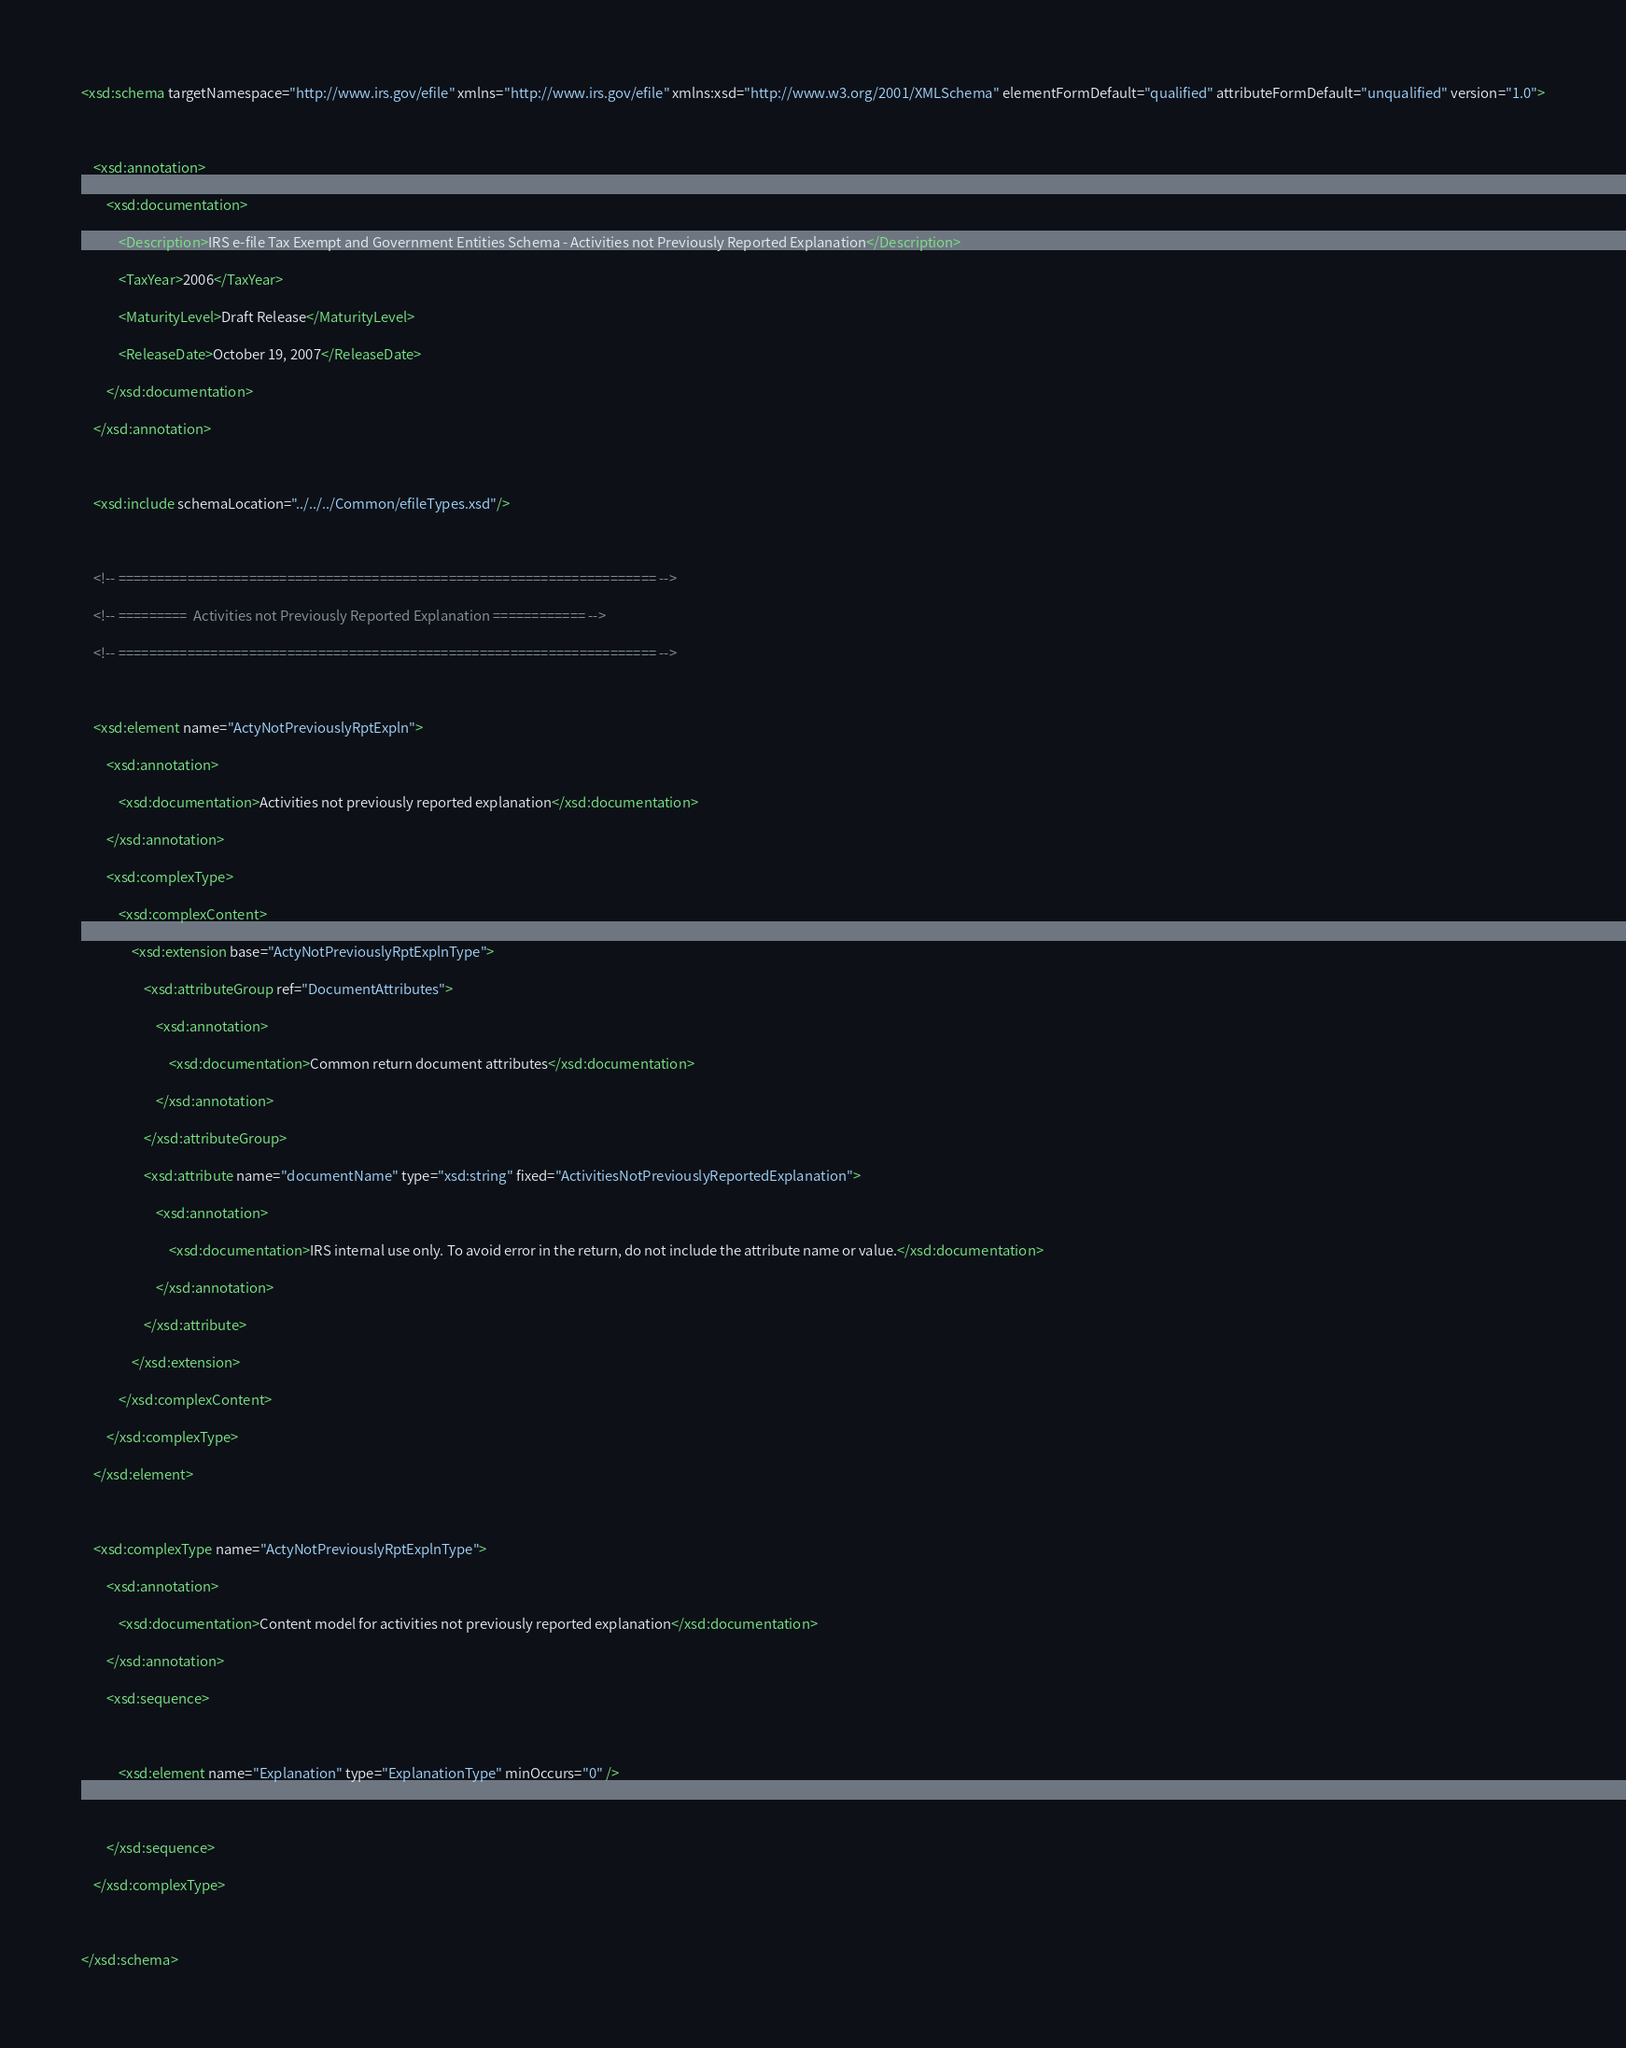Convert code to text. <code><loc_0><loc_0><loc_500><loc_500><_XML_><xsd:schema targetNamespace="http://www.irs.gov/efile" xmlns="http://www.irs.gov/efile" xmlns:xsd="http://www.w3.org/2001/XMLSchema" elementFormDefault="qualified" attributeFormDefault="unqualified" version="1.0">

	<xsd:annotation>
		<xsd:documentation>
			<Description>IRS e-file Tax Exempt and Government Entities Schema - Activities not Previously Reported Explanation</Description>
			<TaxYear>2006</TaxYear>
			<MaturityLevel>Draft Release</MaturityLevel>
			<ReleaseDate>October 19, 2007</ReleaseDate>			
		</xsd:documentation>
	</xsd:annotation>
	
	<xsd:include schemaLocation="../../../Common/efileTypes.xsd"/>
		
	<!-- ====================================================================== -->
	<!-- =========  Activities not Previously Reported Explanation ============ -->
	<!-- ====================================================================== -->
	
	<xsd:element name="ActyNotPreviouslyRptExpln">
		<xsd:annotation>
			<xsd:documentation>Activities not previously reported explanation</xsd:documentation>
		</xsd:annotation>
		<xsd:complexType>
			<xsd:complexContent>
				<xsd:extension base="ActyNotPreviouslyRptExplnType">
					<xsd:attributeGroup ref="DocumentAttributes">
						<xsd:annotation>
							<xsd:documentation>Common return document attributes</xsd:documentation>
						</xsd:annotation>
					</xsd:attributeGroup>
					<xsd:attribute name="documentName" type="xsd:string" fixed="ActivitiesNotPreviouslyReportedExplanation">
						<xsd:annotation>
							<xsd:documentation>IRS internal use only. To avoid error in the return, do not include the attribute name or value.</xsd:documentation>
						</xsd:annotation>
					</xsd:attribute>
				</xsd:extension>
			</xsd:complexContent>
		</xsd:complexType>
	</xsd:element>
	
	<xsd:complexType name="ActyNotPreviouslyRptExplnType">
		<xsd:annotation>
			<xsd:documentation>Content model for activities not previously reported explanation</xsd:documentation>
		</xsd:annotation>
		<xsd:sequence>
		
			<xsd:element name="Explanation" type="ExplanationType" minOccurs="0" />
			
		</xsd:sequence>
	</xsd:complexType>
	
</xsd:schema>
</code> 